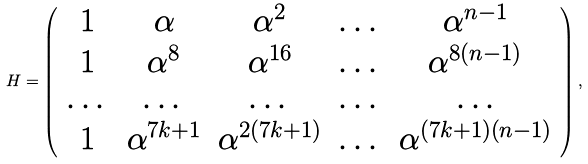<formula> <loc_0><loc_0><loc_500><loc_500>H = \left ( \begin{array} { c c c c c } 1 & \alpha & \alpha ^ { 2 } & \dots & \alpha ^ { n - 1 } \\ 1 & \alpha ^ { 8 } & \alpha ^ { 1 6 } & \dots & \alpha ^ { 8 ( n - 1 ) } \\ \dots & \dots & \dots & \dots & \dots \\ 1 & \alpha ^ { 7 k + 1 } & \alpha ^ { 2 \left ( 7 k + 1 \right ) } & \dots & \alpha ^ { ( 7 k + 1 ) \left ( n - 1 \right ) } \end{array} \right ) ,</formula> 